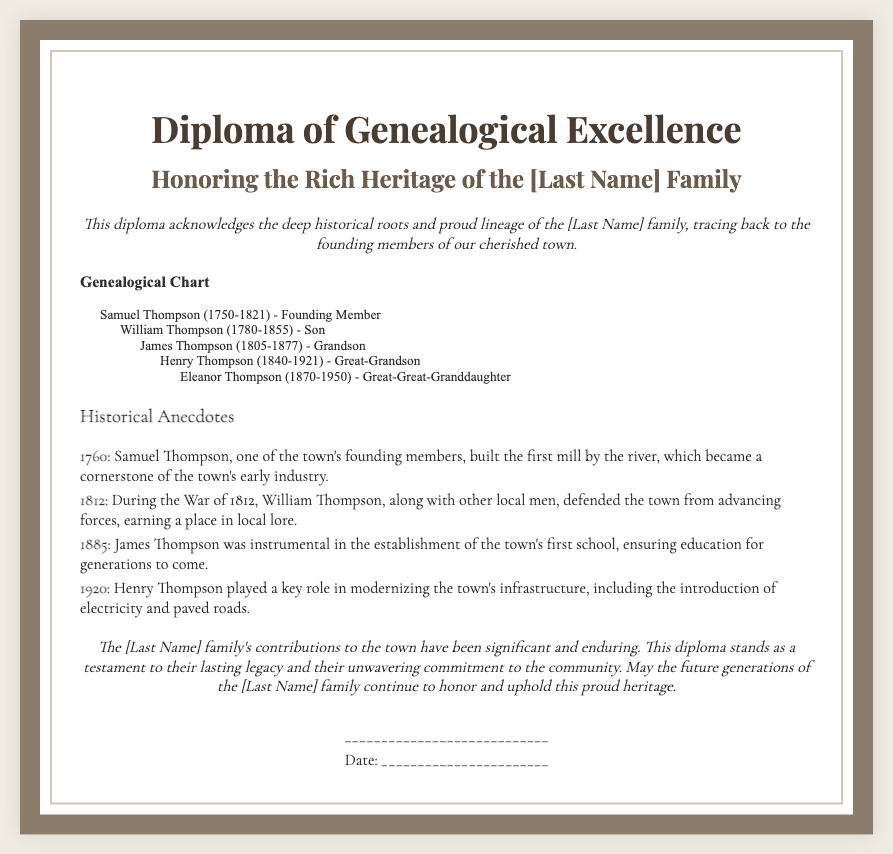What is the name of the founding member? The document lists Samuel Thompson as the founding member of the town.
Answer: Samuel Thompson In which year was the first mill built? The document states that Samuel Thompson built the first mill in 1760.
Answer: 1760 Who is the great-great-granddaughter of Samuel Thompson? The genealogical chart provides the name Eleanor Thompson as the great-great-granddaughter.
Answer: Eleanor Thompson What conflict did William Thompson participate in? The document mentions that William Thompson defended the town during the War of 1812.
Answer: War of 1812 What contribution did James Thompson make in 1885? According to the document, James Thompson was instrumental in establishing the town's first school.
Answer: First school Which family member introduced electricity to the town? The historical anecdote indicates that Henry Thompson played a key role in modernizing the town's infrastructure, including introducing electricity.
Answer: Henry Thompson How many generations are outlined in the genealogical chart? The chart traces the lineage down to four generations from Samuel Thompson to Eleanor Thompson.
Answer: Four generations What is the diploma recognizing? The document acknowledges the deep historical roots and proud lineage of the [Last Name] family.
Answer: Genealogical excellence What is the closing statement's main message? The closing statement emphasizes the lasting legacy and commitment of the [Last Name] family to the community.
Answer: Lasting legacy 